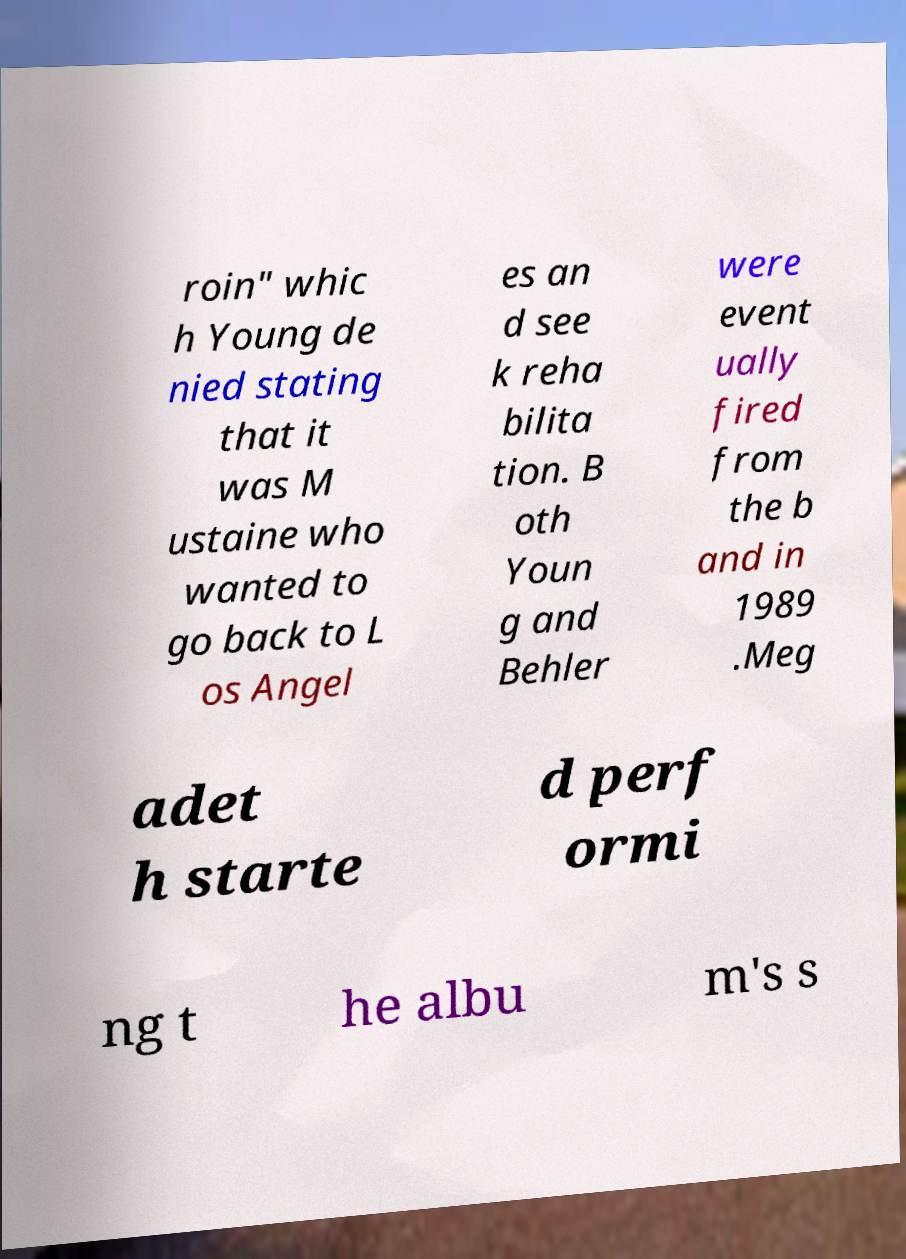Could you extract and type out the text from this image? roin" whic h Young de nied stating that it was M ustaine who wanted to go back to L os Angel es an d see k reha bilita tion. B oth Youn g and Behler were event ually fired from the b and in 1989 .Meg adet h starte d perf ormi ng t he albu m's s 